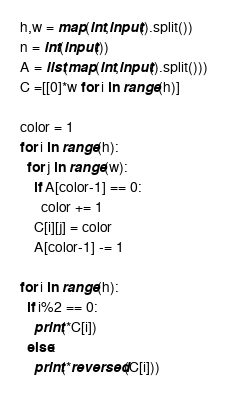<code> <loc_0><loc_0><loc_500><loc_500><_Python_>h,w = map(int,input().split())
n = int(input())
A = list(map(int,input().split()))
C =[[0]*w for i in range(h)] 

color = 1
for i in range(h):
  for j in range(w):
    if A[color-1] == 0:
      color += 1
    C[i][j] = color
    A[color-1] -= 1
    
for i in range(h):
  if i%2 == 0:
    print(*C[i])
  else:
    print(*reversed(C[i]))</code> 